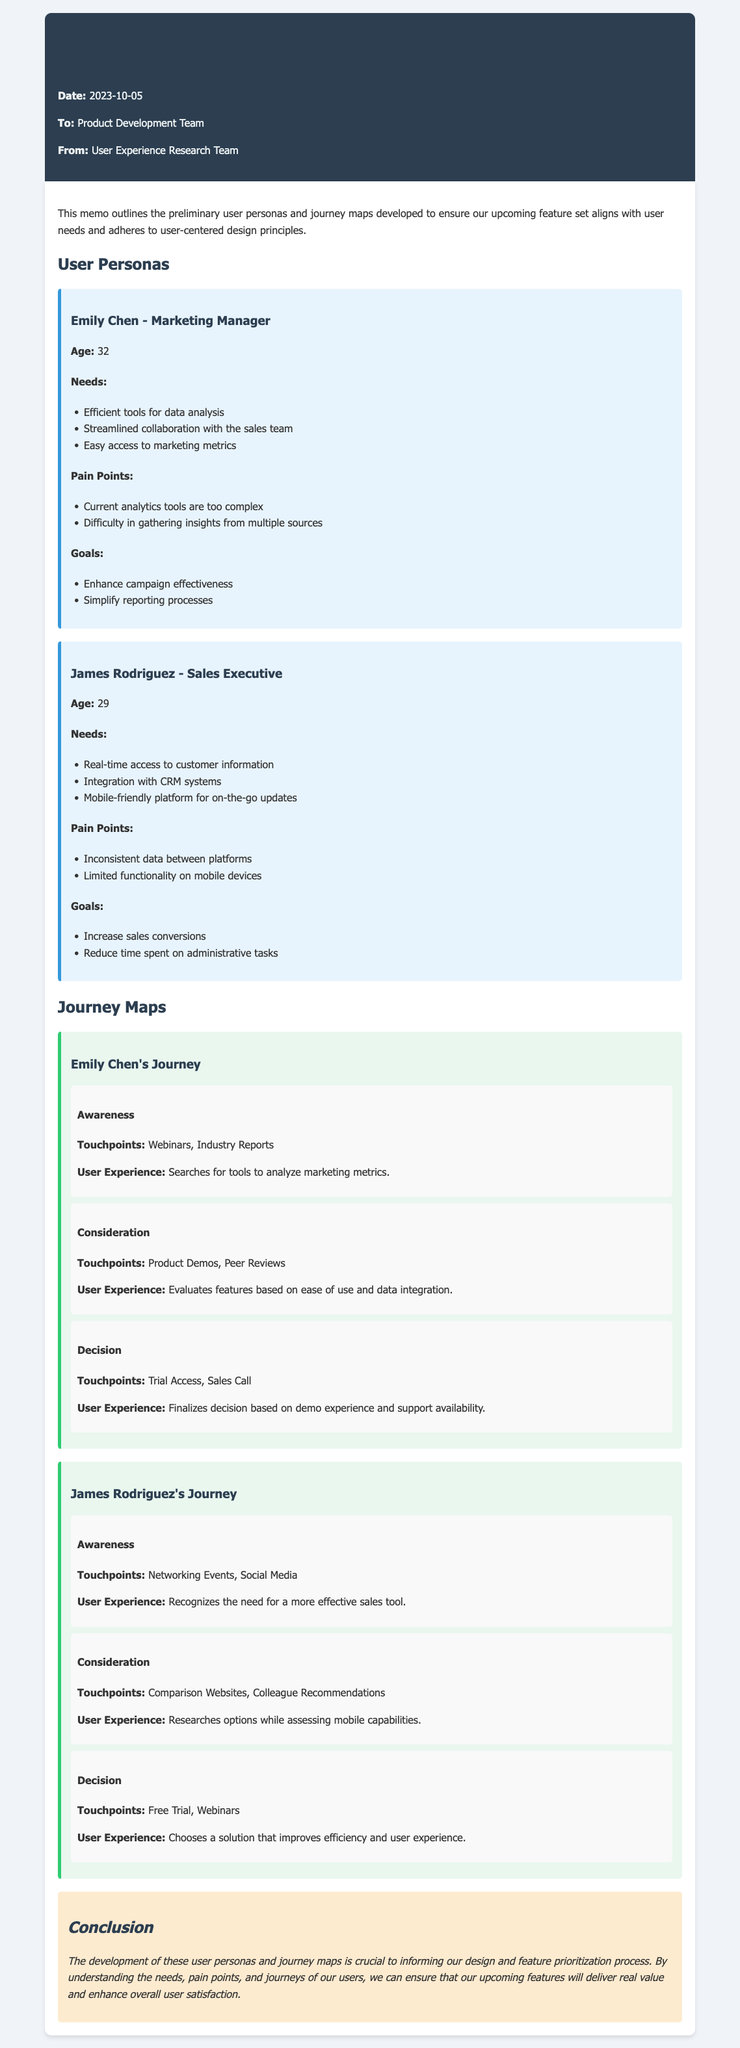What is the date of the memo? The date is stated in the header of the memo as 2023-10-05.
Answer: 2023-10-05 Who is the memo addressed to? The recipient is clearly outlined in the header section as the Product Development Team.
Answer: Product Development Team What is Emily Chen's age? The age of Emily Chen is specified in her user persona section of the memo as 32.
Answer: 32 What is one of James Rodriguez's pain points? The pain points for James Rodriguez are mentioned, including "Inconsistent data between platforms."
Answer: Inconsistent data between platforms During which stage does Emily Chen search for tools? The stage of awareness describes Emily Chen's search for tools, detailing her actions and touchpoints.
Answer: Awareness Which two touchpoints are mentioned in James Rodriguez's consideration stage? The consideration stage lists "Comparison Websites" and "Colleague Recommendations" as touchpoints for James Rodriguez.
Answer: Comparison Websites, Colleague Recommendations What are the goals stated for Emily Chen? Emily Chen's goals include enhancing campaign effectiveness and simplifying reporting processes, clearly listed in her persona section.
Answer: Enhance campaign effectiveness, Simplify reporting processes What is the primary conclusion of the memo? The conclusion emphasizes the importance of user personas and journey maps for informing design and feature prioritization.
Answer: Informing our design and feature prioritization process 